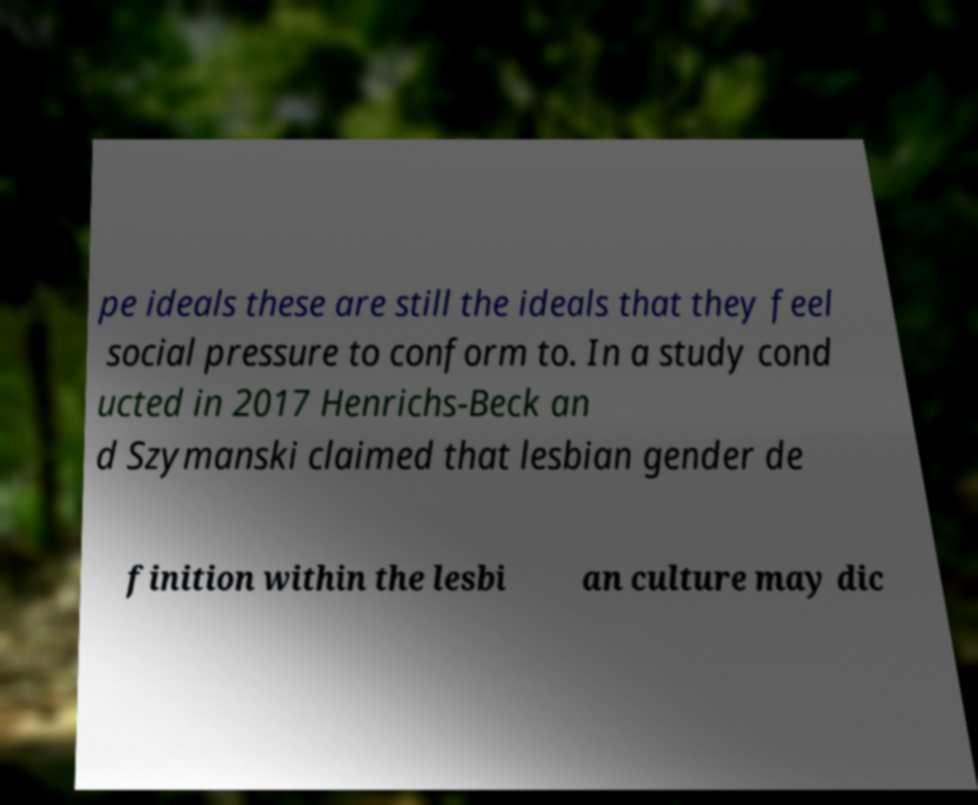Can you read and provide the text displayed in the image?This photo seems to have some interesting text. Can you extract and type it out for me? pe ideals these are still the ideals that they feel social pressure to conform to. In a study cond ucted in 2017 Henrichs-Beck an d Szymanski claimed that lesbian gender de finition within the lesbi an culture may dic 